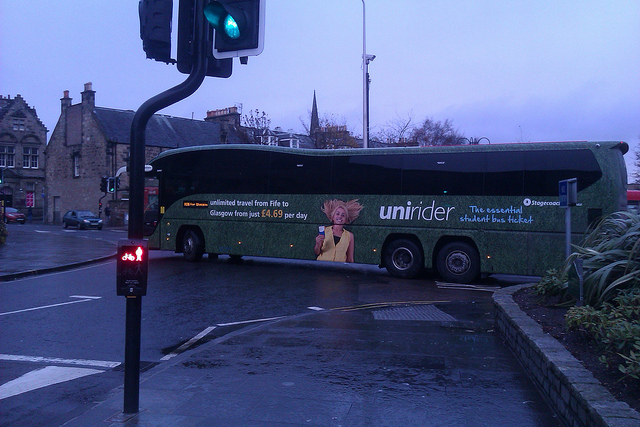Are there any promotional or advertising details visible on the bus? Yes, the bus features promotional details. It advertises 'unirider,' which provides 'unlimited travel from Fife to Glasgow starting at just £4.50 per day.' Furthermore, it emphasizes 'The essential student bus ticket' and includes an image of a person with distinctive spiky hair. 